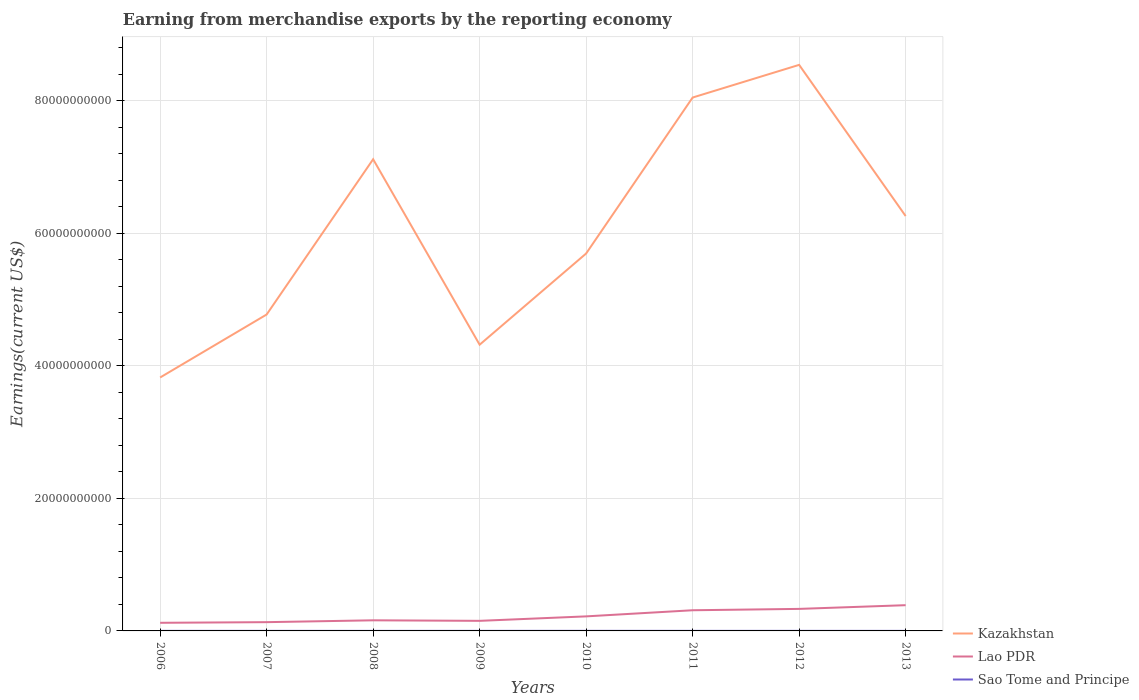Does the line corresponding to Lao PDR intersect with the line corresponding to Kazakhstan?
Make the answer very short. No. Across all years, what is the maximum amount earned from merchandise exports in Lao PDR?
Keep it short and to the point. 1.23e+09. In which year was the amount earned from merchandise exports in Sao Tome and Principe maximum?
Provide a short and direct response. 2008. What is the total amount earned from merchandise exports in Kazakhstan in the graph?
Give a very brief answer. -4.93e+09. What is the difference between the highest and the second highest amount earned from merchandise exports in Lao PDR?
Give a very brief answer. 2.66e+09. What is the difference between the highest and the lowest amount earned from merchandise exports in Kazakhstan?
Your answer should be very brief. 4. Is the amount earned from merchandise exports in Lao PDR strictly greater than the amount earned from merchandise exports in Kazakhstan over the years?
Offer a very short reply. Yes. How many lines are there?
Provide a short and direct response. 3. How many years are there in the graph?
Ensure brevity in your answer.  8. What is the difference between two consecutive major ticks on the Y-axis?
Your response must be concise. 2.00e+1. Does the graph contain grids?
Keep it short and to the point. Yes. How are the legend labels stacked?
Your response must be concise. Vertical. What is the title of the graph?
Ensure brevity in your answer.  Earning from merchandise exports by the reporting economy. Does "Brunei Darussalam" appear as one of the legend labels in the graph?
Provide a short and direct response. No. What is the label or title of the X-axis?
Keep it short and to the point. Years. What is the label or title of the Y-axis?
Give a very brief answer. Earnings(current US$). What is the Earnings(current US$) of Kazakhstan in 2006?
Your answer should be very brief. 3.83e+1. What is the Earnings(current US$) in Lao PDR in 2006?
Provide a short and direct response. 1.23e+09. What is the Earnings(current US$) in Sao Tome and Principe in 2006?
Make the answer very short. 8.39e+06. What is the Earnings(current US$) of Kazakhstan in 2007?
Make the answer very short. 4.78e+1. What is the Earnings(current US$) of Lao PDR in 2007?
Your response must be concise. 1.32e+09. What is the Earnings(current US$) in Sao Tome and Principe in 2007?
Make the answer very short. 8.75e+06. What is the Earnings(current US$) of Kazakhstan in 2008?
Offer a terse response. 7.12e+1. What is the Earnings(current US$) of Lao PDR in 2008?
Ensure brevity in your answer.  1.60e+09. What is the Earnings(current US$) of Sao Tome and Principe in 2008?
Offer a very short reply. 6.57e+06. What is the Earnings(current US$) in Kazakhstan in 2009?
Ensure brevity in your answer.  4.32e+1. What is the Earnings(current US$) of Lao PDR in 2009?
Provide a short and direct response. 1.52e+09. What is the Earnings(current US$) in Sao Tome and Principe in 2009?
Your response must be concise. 9.18e+06. What is the Earnings(current US$) in Kazakhstan in 2010?
Give a very brief answer. 5.70e+1. What is the Earnings(current US$) of Lao PDR in 2010?
Make the answer very short. 2.20e+09. What is the Earnings(current US$) of Sao Tome and Principe in 2010?
Provide a succinct answer. 1.19e+07. What is the Earnings(current US$) in Kazakhstan in 2011?
Keep it short and to the point. 8.05e+1. What is the Earnings(current US$) in Lao PDR in 2011?
Ensure brevity in your answer.  3.12e+09. What is the Earnings(current US$) of Sao Tome and Principe in 2011?
Provide a short and direct response. 8.98e+06. What is the Earnings(current US$) in Kazakhstan in 2012?
Your answer should be very brief. 8.54e+1. What is the Earnings(current US$) in Lao PDR in 2012?
Your answer should be compact. 3.33e+09. What is the Earnings(current US$) in Sao Tome and Principe in 2012?
Your answer should be compact. 8.64e+06. What is the Earnings(current US$) in Kazakhstan in 2013?
Offer a terse response. 6.26e+1. What is the Earnings(current US$) in Lao PDR in 2013?
Provide a short and direct response. 3.88e+09. What is the Earnings(current US$) of Sao Tome and Principe in 2013?
Make the answer very short. 7.57e+06. Across all years, what is the maximum Earnings(current US$) of Kazakhstan?
Your response must be concise. 8.54e+1. Across all years, what is the maximum Earnings(current US$) of Lao PDR?
Offer a very short reply. 3.88e+09. Across all years, what is the maximum Earnings(current US$) in Sao Tome and Principe?
Give a very brief answer. 1.19e+07. Across all years, what is the minimum Earnings(current US$) in Kazakhstan?
Give a very brief answer. 3.83e+1. Across all years, what is the minimum Earnings(current US$) in Lao PDR?
Provide a short and direct response. 1.23e+09. Across all years, what is the minimum Earnings(current US$) of Sao Tome and Principe?
Ensure brevity in your answer.  6.57e+06. What is the total Earnings(current US$) in Kazakhstan in the graph?
Offer a very short reply. 4.86e+11. What is the total Earnings(current US$) of Lao PDR in the graph?
Offer a terse response. 1.82e+1. What is the total Earnings(current US$) of Sao Tome and Principe in the graph?
Your response must be concise. 7.00e+07. What is the difference between the Earnings(current US$) in Kazakhstan in 2006 and that in 2007?
Provide a succinct answer. -9.51e+09. What is the difference between the Earnings(current US$) in Lao PDR in 2006 and that in 2007?
Keep it short and to the point. -9.67e+07. What is the difference between the Earnings(current US$) in Sao Tome and Principe in 2006 and that in 2007?
Your answer should be very brief. -3.64e+05. What is the difference between the Earnings(current US$) of Kazakhstan in 2006 and that in 2008?
Offer a terse response. -3.29e+1. What is the difference between the Earnings(current US$) of Lao PDR in 2006 and that in 2008?
Offer a very short reply. -3.74e+08. What is the difference between the Earnings(current US$) in Sao Tome and Principe in 2006 and that in 2008?
Give a very brief answer. 1.83e+06. What is the difference between the Earnings(current US$) of Kazakhstan in 2006 and that in 2009?
Ensure brevity in your answer.  -4.95e+09. What is the difference between the Earnings(current US$) in Lao PDR in 2006 and that in 2009?
Ensure brevity in your answer.  -2.94e+08. What is the difference between the Earnings(current US$) in Sao Tome and Principe in 2006 and that in 2009?
Make the answer very short. -7.90e+05. What is the difference between the Earnings(current US$) in Kazakhstan in 2006 and that in 2010?
Keep it short and to the point. -1.87e+1. What is the difference between the Earnings(current US$) of Lao PDR in 2006 and that in 2010?
Provide a short and direct response. -9.69e+08. What is the difference between the Earnings(current US$) in Sao Tome and Principe in 2006 and that in 2010?
Provide a succinct answer. -3.49e+06. What is the difference between the Earnings(current US$) in Kazakhstan in 2006 and that in 2011?
Your answer should be very brief. -4.23e+1. What is the difference between the Earnings(current US$) of Lao PDR in 2006 and that in 2011?
Provide a succinct answer. -1.89e+09. What is the difference between the Earnings(current US$) in Sao Tome and Principe in 2006 and that in 2011?
Ensure brevity in your answer.  -5.91e+05. What is the difference between the Earnings(current US$) of Kazakhstan in 2006 and that in 2012?
Provide a succinct answer. -4.72e+1. What is the difference between the Earnings(current US$) in Lao PDR in 2006 and that in 2012?
Provide a succinct answer. -2.10e+09. What is the difference between the Earnings(current US$) in Sao Tome and Principe in 2006 and that in 2012?
Provide a short and direct response. -2.52e+05. What is the difference between the Earnings(current US$) of Kazakhstan in 2006 and that in 2013?
Your answer should be compact. -2.44e+1. What is the difference between the Earnings(current US$) of Lao PDR in 2006 and that in 2013?
Provide a short and direct response. -2.66e+09. What is the difference between the Earnings(current US$) of Sao Tome and Principe in 2006 and that in 2013?
Offer a terse response. 8.24e+05. What is the difference between the Earnings(current US$) of Kazakhstan in 2007 and that in 2008?
Provide a short and direct response. -2.34e+1. What is the difference between the Earnings(current US$) of Lao PDR in 2007 and that in 2008?
Your answer should be very brief. -2.77e+08. What is the difference between the Earnings(current US$) of Sao Tome and Principe in 2007 and that in 2008?
Make the answer very short. 2.19e+06. What is the difference between the Earnings(current US$) in Kazakhstan in 2007 and that in 2009?
Give a very brief answer. 4.56e+09. What is the difference between the Earnings(current US$) of Lao PDR in 2007 and that in 2009?
Provide a short and direct response. -1.98e+08. What is the difference between the Earnings(current US$) in Sao Tome and Principe in 2007 and that in 2009?
Your response must be concise. -4.26e+05. What is the difference between the Earnings(current US$) of Kazakhstan in 2007 and that in 2010?
Give a very brief answer. -9.21e+09. What is the difference between the Earnings(current US$) of Lao PDR in 2007 and that in 2010?
Provide a succinct answer. -8.72e+08. What is the difference between the Earnings(current US$) of Sao Tome and Principe in 2007 and that in 2010?
Keep it short and to the point. -3.13e+06. What is the difference between the Earnings(current US$) of Kazakhstan in 2007 and that in 2011?
Offer a terse response. -3.28e+1. What is the difference between the Earnings(current US$) of Lao PDR in 2007 and that in 2011?
Provide a succinct answer. -1.80e+09. What is the difference between the Earnings(current US$) of Sao Tome and Principe in 2007 and that in 2011?
Your response must be concise. -2.27e+05. What is the difference between the Earnings(current US$) in Kazakhstan in 2007 and that in 2012?
Ensure brevity in your answer.  -3.77e+1. What is the difference between the Earnings(current US$) in Lao PDR in 2007 and that in 2012?
Your response must be concise. -2.00e+09. What is the difference between the Earnings(current US$) in Sao Tome and Principe in 2007 and that in 2012?
Ensure brevity in your answer.  1.12e+05. What is the difference between the Earnings(current US$) of Kazakhstan in 2007 and that in 2013?
Ensure brevity in your answer.  -1.49e+1. What is the difference between the Earnings(current US$) of Lao PDR in 2007 and that in 2013?
Provide a short and direct response. -2.56e+09. What is the difference between the Earnings(current US$) of Sao Tome and Principe in 2007 and that in 2013?
Provide a succinct answer. 1.19e+06. What is the difference between the Earnings(current US$) of Kazakhstan in 2008 and that in 2009?
Offer a terse response. 2.80e+1. What is the difference between the Earnings(current US$) in Lao PDR in 2008 and that in 2009?
Keep it short and to the point. 7.97e+07. What is the difference between the Earnings(current US$) in Sao Tome and Principe in 2008 and that in 2009?
Provide a succinct answer. -2.62e+06. What is the difference between the Earnings(current US$) of Kazakhstan in 2008 and that in 2010?
Make the answer very short. 1.42e+1. What is the difference between the Earnings(current US$) in Lao PDR in 2008 and that in 2010?
Your response must be concise. -5.95e+08. What is the difference between the Earnings(current US$) in Sao Tome and Principe in 2008 and that in 2010?
Your answer should be compact. -5.32e+06. What is the difference between the Earnings(current US$) in Kazakhstan in 2008 and that in 2011?
Give a very brief answer. -9.32e+09. What is the difference between the Earnings(current US$) in Lao PDR in 2008 and that in 2011?
Your response must be concise. -1.52e+09. What is the difference between the Earnings(current US$) of Sao Tome and Principe in 2008 and that in 2011?
Make the answer very short. -2.42e+06. What is the difference between the Earnings(current US$) in Kazakhstan in 2008 and that in 2012?
Ensure brevity in your answer.  -1.42e+1. What is the difference between the Earnings(current US$) of Lao PDR in 2008 and that in 2012?
Keep it short and to the point. -1.73e+09. What is the difference between the Earnings(current US$) in Sao Tome and Principe in 2008 and that in 2012?
Offer a very short reply. -2.08e+06. What is the difference between the Earnings(current US$) of Kazakhstan in 2008 and that in 2013?
Offer a very short reply. 8.57e+09. What is the difference between the Earnings(current US$) of Lao PDR in 2008 and that in 2013?
Ensure brevity in your answer.  -2.28e+09. What is the difference between the Earnings(current US$) in Sao Tome and Principe in 2008 and that in 2013?
Your answer should be very brief. -1.00e+06. What is the difference between the Earnings(current US$) in Kazakhstan in 2009 and that in 2010?
Your answer should be compact. -1.38e+1. What is the difference between the Earnings(current US$) of Lao PDR in 2009 and that in 2010?
Provide a short and direct response. -6.75e+08. What is the difference between the Earnings(current US$) of Sao Tome and Principe in 2009 and that in 2010?
Your response must be concise. -2.70e+06. What is the difference between the Earnings(current US$) of Kazakhstan in 2009 and that in 2011?
Provide a succinct answer. -3.73e+1. What is the difference between the Earnings(current US$) of Lao PDR in 2009 and that in 2011?
Ensure brevity in your answer.  -1.60e+09. What is the difference between the Earnings(current US$) of Sao Tome and Principe in 2009 and that in 2011?
Provide a short and direct response. 1.99e+05. What is the difference between the Earnings(current US$) of Kazakhstan in 2009 and that in 2012?
Give a very brief answer. -4.22e+1. What is the difference between the Earnings(current US$) of Lao PDR in 2009 and that in 2012?
Offer a terse response. -1.81e+09. What is the difference between the Earnings(current US$) in Sao Tome and Principe in 2009 and that in 2012?
Ensure brevity in your answer.  5.38e+05. What is the difference between the Earnings(current US$) of Kazakhstan in 2009 and that in 2013?
Ensure brevity in your answer.  -1.94e+1. What is the difference between the Earnings(current US$) of Lao PDR in 2009 and that in 2013?
Your response must be concise. -2.36e+09. What is the difference between the Earnings(current US$) of Sao Tome and Principe in 2009 and that in 2013?
Ensure brevity in your answer.  1.61e+06. What is the difference between the Earnings(current US$) of Kazakhstan in 2010 and that in 2011?
Your answer should be compact. -2.35e+1. What is the difference between the Earnings(current US$) in Lao PDR in 2010 and that in 2011?
Offer a very short reply. -9.25e+08. What is the difference between the Earnings(current US$) of Sao Tome and Principe in 2010 and that in 2011?
Ensure brevity in your answer.  2.90e+06. What is the difference between the Earnings(current US$) of Kazakhstan in 2010 and that in 2012?
Provide a succinct answer. -2.85e+1. What is the difference between the Earnings(current US$) in Lao PDR in 2010 and that in 2012?
Ensure brevity in your answer.  -1.13e+09. What is the difference between the Earnings(current US$) in Sao Tome and Principe in 2010 and that in 2012?
Keep it short and to the point. 3.24e+06. What is the difference between the Earnings(current US$) of Kazakhstan in 2010 and that in 2013?
Ensure brevity in your answer.  -5.66e+09. What is the difference between the Earnings(current US$) of Lao PDR in 2010 and that in 2013?
Ensure brevity in your answer.  -1.69e+09. What is the difference between the Earnings(current US$) of Sao Tome and Principe in 2010 and that in 2013?
Give a very brief answer. 4.31e+06. What is the difference between the Earnings(current US$) in Kazakhstan in 2011 and that in 2012?
Your answer should be compact. -4.93e+09. What is the difference between the Earnings(current US$) of Lao PDR in 2011 and that in 2012?
Provide a short and direct response. -2.05e+08. What is the difference between the Earnings(current US$) in Sao Tome and Principe in 2011 and that in 2012?
Offer a terse response. 3.39e+05. What is the difference between the Earnings(current US$) of Kazakhstan in 2011 and that in 2013?
Your answer should be compact. 1.79e+1. What is the difference between the Earnings(current US$) of Lao PDR in 2011 and that in 2013?
Offer a terse response. -7.63e+08. What is the difference between the Earnings(current US$) of Sao Tome and Principe in 2011 and that in 2013?
Offer a very short reply. 1.41e+06. What is the difference between the Earnings(current US$) in Kazakhstan in 2012 and that in 2013?
Make the answer very short. 2.28e+1. What is the difference between the Earnings(current US$) in Lao PDR in 2012 and that in 2013?
Keep it short and to the point. -5.58e+08. What is the difference between the Earnings(current US$) of Sao Tome and Principe in 2012 and that in 2013?
Give a very brief answer. 1.08e+06. What is the difference between the Earnings(current US$) of Kazakhstan in 2006 and the Earnings(current US$) of Lao PDR in 2007?
Give a very brief answer. 3.69e+1. What is the difference between the Earnings(current US$) of Kazakhstan in 2006 and the Earnings(current US$) of Sao Tome and Principe in 2007?
Your response must be concise. 3.82e+1. What is the difference between the Earnings(current US$) in Lao PDR in 2006 and the Earnings(current US$) in Sao Tome and Principe in 2007?
Make the answer very short. 1.22e+09. What is the difference between the Earnings(current US$) in Kazakhstan in 2006 and the Earnings(current US$) in Lao PDR in 2008?
Ensure brevity in your answer.  3.67e+1. What is the difference between the Earnings(current US$) in Kazakhstan in 2006 and the Earnings(current US$) in Sao Tome and Principe in 2008?
Your response must be concise. 3.83e+1. What is the difference between the Earnings(current US$) of Lao PDR in 2006 and the Earnings(current US$) of Sao Tome and Principe in 2008?
Offer a very short reply. 1.22e+09. What is the difference between the Earnings(current US$) in Kazakhstan in 2006 and the Earnings(current US$) in Lao PDR in 2009?
Provide a short and direct response. 3.67e+1. What is the difference between the Earnings(current US$) in Kazakhstan in 2006 and the Earnings(current US$) in Sao Tome and Principe in 2009?
Your response must be concise. 3.82e+1. What is the difference between the Earnings(current US$) in Lao PDR in 2006 and the Earnings(current US$) in Sao Tome and Principe in 2009?
Ensure brevity in your answer.  1.22e+09. What is the difference between the Earnings(current US$) of Kazakhstan in 2006 and the Earnings(current US$) of Lao PDR in 2010?
Your answer should be compact. 3.61e+1. What is the difference between the Earnings(current US$) of Kazakhstan in 2006 and the Earnings(current US$) of Sao Tome and Principe in 2010?
Your answer should be very brief. 3.82e+1. What is the difference between the Earnings(current US$) of Lao PDR in 2006 and the Earnings(current US$) of Sao Tome and Principe in 2010?
Your response must be concise. 1.21e+09. What is the difference between the Earnings(current US$) of Kazakhstan in 2006 and the Earnings(current US$) of Lao PDR in 2011?
Ensure brevity in your answer.  3.51e+1. What is the difference between the Earnings(current US$) in Kazakhstan in 2006 and the Earnings(current US$) in Sao Tome and Principe in 2011?
Offer a very short reply. 3.82e+1. What is the difference between the Earnings(current US$) of Lao PDR in 2006 and the Earnings(current US$) of Sao Tome and Principe in 2011?
Offer a very short reply. 1.22e+09. What is the difference between the Earnings(current US$) in Kazakhstan in 2006 and the Earnings(current US$) in Lao PDR in 2012?
Make the answer very short. 3.49e+1. What is the difference between the Earnings(current US$) of Kazakhstan in 2006 and the Earnings(current US$) of Sao Tome and Principe in 2012?
Your answer should be compact. 3.82e+1. What is the difference between the Earnings(current US$) in Lao PDR in 2006 and the Earnings(current US$) in Sao Tome and Principe in 2012?
Offer a terse response. 1.22e+09. What is the difference between the Earnings(current US$) of Kazakhstan in 2006 and the Earnings(current US$) of Lao PDR in 2013?
Provide a short and direct response. 3.44e+1. What is the difference between the Earnings(current US$) of Kazakhstan in 2006 and the Earnings(current US$) of Sao Tome and Principe in 2013?
Ensure brevity in your answer.  3.82e+1. What is the difference between the Earnings(current US$) in Lao PDR in 2006 and the Earnings(current US$) in Sao Tome and Principe in 2013?
Offer a very short reply. 1.22e+09. What is the difference between the Earnings(current US$) in Kazakhstan in 2007 and the Earnings(current US$) in Lao PDR in 2008?
Provide a short and direct response. 4.62e+1. What is the difference between the Earnings(current US$) of Kazakhstan in 2007 and the Earnings(current US$) of Sao Tome and Principe in 2008?
Your answer should be very brief. 4.78e+1. What is the difference between the Earnings(current US$) of Lao PDR in 2007 and the Earnings(current US$) of Sao Tome and Principe in 2008?
Your answer should be very brief. 1.32e+09. What is the difference between the Earnings(current US$) of Kazakhstan in 2007 and the Earnings(current US$) of Lao PDR in 2009?
Provide a succinct answer. 4.62e+1. What is the difference between the Earnings(current US$) of Kazakhstan in 2007 and the Earnings(current US$) of Sao Tome and Principe in 2009?
Make the answer very short. 4.78e+1. What is the difference between the Earnings(current US$) in Lao PDR in 2007 and the Earnings(current US$) in Sao Tome and Principe in 2009?
Provide a short and direct response. 1.31e+09. What is the difference between the Earnings(current US$) in Kazakhstan in 2007 and the Earnings(current US$) in Lao PDR in 2010?
Your answer should be compact. 4.56e+1. What is the difference between the Earnings(current US$) of Kazakhstan in 2007 and the Earnings(current US$) of Sao Tome and Principe in 2010?
Offer a very short reply. 4.78e+1. What is the difference between the Earnings(current US$) in Lao PDR in 2007 and the Earnings(current US$) in Sao Tome and Principe in 2010?
Keep it short and to the point. 1.31e+09. What is the difference between the Earnings(current US$) in Kazakhstan in 2007 and the Earnings(current US$) in Lao PDR in 2011?
Keep it short and to the point. 4.46e+1. What is the difference between the Earnings(current US$) of Kazakhstan in 2007 and the Earnings(current US$) of Sao Tome and Principe in 2011?
Keep it short and to the point. 4.78e+1. What is the difference between the Earnings(current US$) in Lao PDR in 2007 and the Earnings(current US$) in Sao Tome and Principe in 2011?
Provide a short and direct response. 1.31e+09. What is the difference between the Earnings(current US$) of Kazakhstan in 2007 and the Earnings(current US$) of Lao PDR in 2012?
Offer a terse response. 4.44e+1. What is the difference between the Earnings(current US$) of Kazakhstan in 2007 and the Earnings(current US$) of Sao Tome and Principe in 2012?
Your response must be concise. 4.78e+1. What is the difference between the Earnings(current US$) in Lao PDR in 2007 and the Earnings(current US$) in Sao Tome and Principe in 2012?
Your response must be concise. 1.31e+09. What is the difference between the Earnings(current US$) of Kazakhstan in 2007 and the Earnings(current US$) of Lao PDR in 2013?
Make the answer very short. 4.39e+1. What is the difference between the Earnings(current US$) of Kazakhstan in 2007 and the Earnings(current US$) of Sao Tome and Principe in 2013?
Offer a very short reply. 4.78e+1. What is the difference between the Earnings(current US$) in Lao PDR in 2007 and the Earnings(current US$) in Sao Tome and Principe in 2013?
Offer a very short reply. 1.32e+09. What is the difference between the Earnings(current US$) in Kazakhstan in 2008 and the Earnings(current US$) in Lao PDR in 2009?
Offer a terse response. 6.97e+1. What is the difference between the Earnings(current US$) in Kazakhstan in 2008 and the Earnings(current US$) in Sao Tome and Principe in 2009?
Keep it short and to the point. 7.12e+1. What is the difference between the Earnings(current US$) of Lao PDR in 2008 and the Earnings(current US$) of Sao Tome and Principe in 2009?
Provide a short and direct response. 1.59e+09. What is the difference between the Earnings(current US$) of Kazakhstan in 2008 and the Earnings(current US$) of Lao PDR in 2010?
Your answer should be very brief. 6.90e+1. What is the difference between the Earnings(current US$) of Kazakhstan in 2008 and the Earnings(current US$) of Sao Tome and Principe in 2010?
Offer a very short reply. 7.12e+1. What is the difference between the Earnings(current US$) in Lao PDR in 2008 and the Earnings(current US$) in Sao Tome and Principe in 2010?
Your answer should be compact. 1.59e+09. What is the difference between the Earnings(current US$) of Kazakhstan in 2008 and the Earnings(current US$) of Lao PDR in 2011?
Your answer should be very brief. 6.81e+1. What is the difference between the Earnings(current US$) of Kazakhstan in 2008 and the Earnings(current US$) of Sao Tome and Principe in 2011?
Your answer should be very brief. 7.12e+1. What is the difference between the Earnings(current US$) in Lao PDR in 2008 and the Earnings(current US$) in Sao Tome and Principe in 2011?
Your response must be concise. 1.59e+09. What is the difference between the Earnings(current US$) of Kazakhstan in 2008 and the Earnings(current US$) of Lao PDR in 2012?
Your response must be concise. 6.79e+1. What is the difference between the Earnings(current US$) in Kazakhstan in 2008 and the Earnings(current US$) in Sao Tome and Principe in 2012?
Offer a terse response. 7.12e+1. What is the difference between the Earnings(current US$) in Lao PDR in 2008 and the Earnings(current US$) in Sao Tome and Principe in 2012?
Your answer should be very brief. 1.59e+09. What is the difference between the Earnings(current US$) of Kazakhstan in 2008 and the Earnings(current US$) of Lao PDR in 2013?
Keep it short and to the point. 6.73e+1. What is the difference between the Earnings(current US$) of Kazakhstan in 2008 and the Earnings(current US$) of Sao Tome and Principe in 2013?
Offer a very short reply. 7.12e+1. What is the difference between the Earnings(current US$) in Lao PDR in 2008 and the Earnings(current US$) in Sao Tome and Principe in 2013?
Your answer should be compact. 1.59e+09. What is the difference between the Earnings(current US$) in Kazakhstan in 2009 and the Earnings(current US$) in Lao PDR in 2010?
Make the answer very short. 4.10e+1. What is the difference between the Earnings(current US$) of Kazakhstan in 2009 and the Earnings(current US$) of Sao Tome and Principe in 2010?
Your response must be concise. 4.32e+1. What is the difference between the Earnings(current US$) in Lao PDR in 2009 and the Earnings(current US$) in Sao Tome and Principe in 2010?
Keep it short and to the point. 1.51e+09. What is the difference between the Earnings(current US$) in Kazakhstan in 2009 and the Earnings(current US$) in Lao PDR in 2011?
Make the answer very short. 4.01e+1. What is the difference between the Earnings(current US$) of Kazakhstan in 2009 and the Earnings(current US$) of Sao Tome and Principe in 2011?
Make the answer very short. 4.32e+1. What is the difference between the Earnings(current US$) in Lao PDR in 2009 and the Earnings(current US$) in Sao Tome and Principe in 2011?
Make the answer very short. 1.51e+09. What is the difference between the Earnings(current US$) of Kazakhstan in 2009 and the Earnings(current US$) of Lao PDR in 2012?
Ensure brevity in your answer.  3.99e+1. What is the difference between the Earnings(current US$) in Kazakhstan in 2009 and the Earnings(current US$) in Sao Tome and Principe in 2012?
Your answer should be compact. 4.32e+1. What is the difference between the Earnings(current US$) of Lao PDR in 2009 and the Earnings(current US$) of Sao Tome and Principe in 2012?
Ensure brevity in your answer.  1.51e+09. What is the difference between the Earnings(current US$) of Kazakhstan in 2009 and the Earnings(current US$) of Lao PDR in 2013?
Make the answer very short. 3.93e+1. What is the difference between the Earnings(current US$) in Kazakhstan in 2009 and the Earnings(current US$) in Sao Tome and Principe in 2013?
Offer a terse response. 4.32e+1. What is the difference between the Earnings(current US$) in Lao PDR in 2009 and the Earnings(current US$) in Sao Tome and Principe in 2013?
Ensure brevity in your answer.  1.51e+09. What is the difference between the Earnings(current US$) in Kazakhstan in 2010 and the Earnings(current US$) in Lao PDR in 2011?
Ensure brevity in your answer.  5.39e+1. What is the difference between the Earnings(current US$) in Kazakhstan in 2010 and the Earnings(current US$) in Sao Tome and Principe in 2011?
Your response must be concise. 5.70e+1. What is the difference between the Earnings(current US$) in Lao PDR in 2010 and the Earnings(current US$) in Sao Tome and Principe in 2011?
Make the answer very short. 2.19e+09. What is the difference between the Earnings(current US$) of Kazakhstan in 2010 and the Earnings(current US$) of Lao PDR in 2012?
Offer a very short reply. 5.36e+1. What is the difference between the Earnings(current US$) in Kazakhstan in 2010 and the Earnings(current US$) in Sao Tome and Principe in 2012?
Ensure brevity in your answer.  5.70e+1. What is the difference between the Earnings(current US$) of Lao PDR in 2010 and the Earnings(current US$) of Sao Tome and Principe in 2012?
Your answer should be very brief. 2.19e+09. What is the difference between the Earnings(current US$) of Kazakhstan in 2010 and the Earnings(current US$) of Lao PDR in 2013?
Keep it short and to the point. 5.31e+1. What is the difference between the Earnings(current US$) in Kazakhstan in 2010 and the Earnings(current US$) in Sao Tome and Principe in 2013?
Ensure brevity in your answer.  5.70e+1. What is the difference between the Earnings(current US$) of Lao PDR in 2010 and the Earnings(current US$) of Sao Tome and Principe in 2013?
Offer a terse response. 2.19e+09. What is the difference between the Earnings(current US$) of Kazakhstan in 2011 and the Earnings(current US$) of Lao PDR in 2012?
Ensure brevity in your answer.  7.72e+1. What is the difference between the Earnings(current US$) in Kazakhstan in 2011 and the Earnings(current US$) in Sao Tome and Principe in 2012?
Make the answer very short. 8.05e+1. What is the difference between the Earnings(current US$) of Lao PDR in 2011 and the Earnings(current US$) of Sao Tome and Principe in 2012?
Keep it short and to the point. 3.11e+09. What is the difference between the Earnings(current US$) in Kazakhstan in 2011 and the Earnings(current US$) in Lao PDR in 2013?
Your response must be concise. 7.66e+1. What is the difference between the Earnings(current US$) of Kazakhstan in 2011 and the Earnings(current US$) of Sao Tome and Principe in 2013?
Your answer should be compact. 8.05e+1. What is the difference between the Earnings(current US$) of Lao PDR in 2011 and the Earnings(current US$) of Sao Tome and Principe in 2013?
Your response must be concise. 3.11e+09. What is the difference between the Earnings(current US$) of Kazakhstan in 2012 and the Earnings(current US$) of Lao PDR in 2013?
Keep it short and to the point. 8.16e+1. What is the difference between the Earnings(current US$) in Kazakhstan in 2012 and the Earnings(current US$) in Sao Tome and Principe in 2013?
Your answer should be compact. 8.54e+1. What is the difference between the Earnings(current US$) of Lao PDR in 2012 and the Earnings(current US$) of Sao Tome and Principe in 2013?
Provide a succinct answer. 3.32e+09. What is the average Earnings(current US$) of Kazakhstan per year?
Keep it short and to the point. 6.07e+1. What is the average Earnings(current US$) of Lao PDR per year?
Offer a very short reply. 2.27e+09. What is the average Earnings(current US$) in Sao Tome and Principe per year?
Your answer should be compact. 8.75e+06. In the year 2006, what is the difference between the Earnings(current US$) in Kazakhstan and Earnings(current US$) in Lao PDR?
Offer a very short reply. 3.70e+1. In the year 2006, what is the difference between the Earnings(current US$) in Kazakhstan and Earnings(current US$) in Sao Tome and Principe?
Keep it short and to the point. 3.82e+1. In the year 2006, what is the difference between the Earnings(current US$) of Lao PDR and Earnings(current US$) of Sao Tome and Principe?
Give a very brief answer. 1.22e+09. In the year 2007, what is the difference between the Earnings(current US$) in Kazakhstan and Earnings(current US$) in Lao PDR?
Provide a short and direct response. 4.64e+1. In the year 2007, what is the difference between the Earnings(current US$) of Kazakhstan and Earnings(current US$) of Sao Tome and Principe?
Your response must be concise. 4.78e+1. In the year 2007, what is the difference between the Earnings(current US$) in Lao PDR and Earnings(current US$) in Sao Tome and Principe?
Your answer should be compact. 1.31e+09. In the year 2008, what is the difference between the Earnings(current US$) of Kazakhstan and Earnings(current US$) of Lao PDR?
Make the answer very short. 6.96e+1. In the year 2008, what is the difference between the Earnings(current US$) of Kazakhstan and Earnings(current US$) of Sao Tome and Principe?
Keep it short and to the point. 7.12e+1. In the year 2008, what is the difference between the Earnings(current US$) in Lao PDR and Earnings(current US$) in Sao Tome and Principe?
Offer a very short reply. 1.59e+09. In the year 2009, what is the difference between the Earnings(current US$) in Kazakhstan and Earnings(current US$) in Lao PDR?
Make the answer very short. 4.17e+1. In the year 2009, what is the difference between the Earnings(current US$) in Kazakhstan and Earnings(current US$) in Sao Tome and Principe?
Keep it short and to the point. 4.32e+1. In the year 2009, what is the difference between the Earnings(current US$) of Lao PDR and Earnings(current US$) of Sao Tome and Principe?
Your response must be concise. 1.51e+09. In the year 2010, what is the difference between the Earnings(current US$) of Kazakhstan and Earnings(current US$) of Lao PDR?
Give a very brief answer. 5.48e+1. In the year 2010, what is the difference between the Earnings(current US$) in Kazakhstan and Earnings(current US$) in Sao Tome and Principe?
Provide a short and direct response. 5.70e+1. In the year 2010, what is the difference between the Earnings(current US$) of Lao PDR and Earnings(current US$) of Sao Tome and Principe?
Offer a very short reply. 2.18e+09. In the year 2011, what is the difference between the Earnings(current US$) in Kazakhstan and Earnings(current US$) in Lao PDR?
Keep it short and to the point. 7.74e+1. In the year 2011, what is the difference between the Earnings(current US$) of Kazakhstan and Earnings(current US$) of Sao Tome and Principe?
Your answer should be compact. 8.05e+1. In the year 2011, what is the difference between the Earnings(current US$) of Lao PDR and Earnings(current US$) of Sao Tome and Principe?
Your response must be concise. 3.11e+09. In the year 2012, what is the difference between the Earnings(current US$) in Kazakhstan and Earnings(current US$) in Lao PDR?
Your response must be concise. 8.21e+1. In the year 2012, what is the difference between the Earnings(current US$) of Kazakhstan and Earnings(current US$) of Sao Tome and Principe?
Your response must be concise. 8.54e+1. In the year 2012, what is the difference between the Earnings(current US$) of Lao PDR and Earnings(current US$) of Sao Tome and Principe?
Your response must be concise. 3.32e+09. In the year 2013, what is the difference between the Earnings(current US$) of Kazakhstan and Earnings(current US$) of Lao PDR?
Your answer should be very brief. 5.87e+1. In the year 2013, what is the difference between the Earnings(current US$) of Kazakhstan and Earnings(current US$) of Sao Tome and Principe?
Ensure brevity in your answer.  6.26e+1. In the year 2013, what is the difference between the Earnings(current US$) of Lao PDR and Earnings(current US$) of Sao Tome and Principe?
Your answer should be very brief. 3.88e+09. What is the ratio of the Earnings(current US$) in Kazakhstan in 2006 to that in 2007?
Your answer should be compact. 0.8. What is the ratio of the Earnings(current US$) in Lao PDR in 2006 to that in 2007?
Provide a short and direct response. 0.93. What is the ratio of the Earnings(current US$) in Sao Tome and Principe in 2006 to that in 2007?
Make the answer very short. 0.96. What is the ratio of the Earnings(current US$) in Kazakhstan in 2006 to that in 2008?
Offer a very short reply. 0.54. What is the ratio of the Earnings(current US$) in Lao PDR in 2006 to that in 2008?
Provide a succinct answer. 0.77. What is the ratio of the Earnings(current US$) in Sao Tome and Principe in 2006 to that in 2008?
Make the answer very short. 1.28. What is the ratio of the Earnings(current US$) in Kazakhstan in 2006 to that in 2009?
Provide a short and direct response. 0.89. What is the ratio of the Earnings(current US$) of Lao PDR in 2006 to that in 2009?
Provide a short and direct response. 0.81. What is the ratio of the Earnings(current US$) in Sao Tome and Principe in 2006 to that in 2009?
Offer a terse response. 0.91. What is the ratio of the Earnings(current US$) in Kazakhstan in 2006 to that in 2010?
Your answer should be compact. 0.67. What is the ratio of the Earnings(current US$) of Lao PDR in 2006 to that in 2010?
Offer a terse response. 0.56. What is the ratio of the Earnings(current US$) of Sao Tome and Principe in 2006 to that in 2010?
Offer a very short reply. 0.71. What is the ratio of the Earnings(current US$) in Kazakhstan in 2006 to that in 2011?
Ensure brevity in your answer.  0.48. What is the ratio of the Earnings(current US$) in Lao PDR in 2006 to that in 2011?
Keep it short and to the point. 0.39. What is the ratio of the Earnings(current US$) in Sao Tome and Principe in 2006 to that in 2011?
Provide a succinct answer. 0.93. What is the ratio of the Earnings(current US$) in Kazakhstan in 2006 to that in 2012?
Offer a very short reply. 0.45. What is the ratio of the Earnings(current US$) in Lao PDR in 2006 to that in 2012?
Provide a succinct answer. 0.37. What is the ratio of the Earnings(current US$) of Sao Tome and Principe in 2006 to that in 2012?
Your answer should be very brief. 0.97. What is the ratio of the Earnings(current US$) of Kazakhstan in 2006 to that in 2013?
Provide a succinct answer. 0.61. What is the ratio of the Earnings(current US$) of Lao PDR in 2006 to that in 2013?
Offer a very short reply. 0.32. What is the ratio of the Earnings(current US$) in Sao Tome and Principe in 2006 to that in 2013?
Ensure brevity in your answer.  1.11. What is the ratio of the Earnings(current US$) in Kazakhstan in 2007 to that in 2008?
Your response must be concise. 0.67. What is the ratio of the Earnings(current US$) of Lao PDR in 2007 to that in 2008?
Give a very brief answer. 0.83. What is the ratio of the Earnings(current US$) in Sao Tome and Principe in 2007 to that in 2008?
Your answer should be compact. 1.33. What is the ratio of the Earnings(current US$) of Kazakhstan in 2007 to that in 2009?
Offer a terse response. 1.11. What is the ratio of the Earnings(current US$) in Lao PDR in 2007 to that in 2009?
Provide a short and direct response. 0.87. What is the ratio of the Earnings(current US$) of Sao Tome and Principe in 2007 to that in 2009?
Ensure brevity in your answer.  0.95. What is the ratio of the Earnings(current US$) in Kazakhstan in 2007 to that in 2010?
Your answer should be very brief. 0.84. What is the ratio of the Earnings(current US$) of Lao PDR in 2007 to that in 2010?
Your answer should be compact. 0.6. What is the ratio of the Earnings(current US$) of Sao Tome and Principe in 2007 to that in 2010?
Your answer should be compact. 0.74. What is the ratio of the Earnings(current US$) in Kazakhstan in 2007 to that in 2011?
Your answer should be very brief. 0.59. What is the ratio of the Earnings(current US$) in Lao PDR in 2007 to that in 2011?
Offer a very short reply. 0.42. What is the ratio of the Earnings(current US$) in Sao Tome and Principe in 2007 to that in 2011?
Your answer should be compact. 0.97. What is the ratio of the Earnings(current US$) in Kazakhstan in 2007 to that in 2012?
Your response must be concise. 0.56. What is the ratio of the Earnings(current US$) of Lao PDR in 2007 to that in 2012?
Your answer should be compact. 0.4. What is the ratio of the Earnings(current US$) in Sao Tome and Principe in 2007 to that in 2012?
Make the answer very short. 1.01. What is the ratio of the Earnings(current US$) of Kazakhstan in 2007 to that in 2013?
Your answer should be compact. 0.76. What is the ratio of the Earnings(current US$) in Lao PDR in 2007 to that in 2013?
Provide a succinct answer. 0.34. What is the ratio of the Earnings(current US$) of Sao Tome and Principe in 2007 to that in 2013?
Ensure brevity in your answer.  1.16. What is the ratio of the Earnings(current US$) in Kazakhstan in 2008 to that in 2009?
Provide a succinct answer. 1.65. What is the ratio of the Earnings(current US$) in Lao PDR in 2008 to that in 2009?
Make the answer very short. 1.05. What is the ratio of the Earnings(current US$) of Sao Tome and Principe in 2008 to that in 2009?
Offer a very short reply. 0.72. What is the ratio of the Earnings(current US$) in Kazakhstan in 2008 to that in 2010?
Make the answer very short. 1.25. What is the ratio of the Earnings(current US$) in Lao PDR in 2008 to that in 2010?
Provide a short and direct response. 0.73. What is the ratio of the Earnings(current US$) of Sao Tome and Principe in 2008 to that in 2010?
Ensure brevity in your answer.  0.55. What is the ratio of the Earnings(current US$) in Kazakhstan in 2008 to that in 2011?
Give a very brief answer. 0.88. What is the ratio of the Earnings(current US$) in Lao PDR in 2008 to that in 2011?
Offer a very short reply. 0.51. What is the ratio of the Earnings(current US$) in Sao Tome and Principe in 2008 to that in 2011?
Keep it short and to the point. 0.73. What is the ratio of the Earnings(current US$) of Kazakhstan in 2008 to that in 2012?
Ensure brevity in your answer.  0.83. What is the ratio of the Earnings(current US$) in Lao PDR in 2008 to that in 2012?
Provide a short and direct response. 0.48. What is the ratio of the Earnings(current US$) in Sao Tome and Principe in 2008 to that in 2012?
Offer a very short reply. 0.76. What is the ratio of the Earnings(current US$) of Kazakhstan in 2008 to that in 2013?
Your answer should be very brief. 1.14. What is the ratio of the Earnings(current US$) of Lao PDR in 2008 to that in 2013?
Offer a very short reply. 0.41. What is the ratio of the Earnings(current US$) in Sao Tome and Principe in 2008 to that in 2013?
Give a very brief answer. 0.87. What is the ratio of the Earnings(current US$) in Kazakhstan in 2009 to that in 2010?
Offer a terse response. 0.76. What is the ratio of the Earnings(current US$) in Lao PDR in 2009 to that in 2010?
Give a very brief answer. 0.69. What is the ratio of the Earnings(current US$) of Sao Tome and Principe in 2009 to that in 2010?
Ensure brevity in your answer.  0.77. What is the ratio of the Earnings(current US$) in Kazakhstan in 2009 to that in 2011?
Offer a terse response. 0.54. What is the ratio of the Earnings(current US$) in Lao PDR in 2009 to that in 2011?
Provide a short and direct response. 0.49. What is the ratio of the Earnings(current US$) in Sao Tome and Principe in 2009 to that in 2011?
Keep it short and to the point. 1.02. What is the ratio of the Earnings(current US$) in Kazakhstan in 2009 to that in 2012?
Your answer should be compact. 0.51. What is the ratio of the Earnings(current US$) in Lao PDR in 2009 to that in 2012?
Your answer should be compact. 0.46. What is the ratio of the Earnings(current US$) of Sao Tome and Principe in 2009 to that in 2012?
Make the answer very short. 1.06. What is the ratio of the Earnings(current US$) in Kazakhstan in 2009 to that in 2013?
Keep it short and to the point. 0.69. What is the ratio of the Earnings(current US$) of Lao PDR in 2009 to that in 2013?
Offer a terse response. 0.39. What is the ratio of the Earnings(current US$) of Sao Tome and Principe in 2009 to that in 2013?
Your response must be concise. 1.21. What is the ratio of the Earnings(current US$) of Kazakhstan in 2010 to that in 2011?
Provide a short and direct response. 0.71. What is the ratio of the Earnings(current US$) in Lao PDR in 2010 to that in 2011?
Make the answer very short. 0.7. What is the ratio of the Earnings(current US$) of Sao Tome and Principe in 2010 to that in 2011?
Ensure brevity in your answer.  1.32. What is the ratio of the Earnings(current US$) in Kazakhstan in 2010 to that in 2012?
Your answer should be very brief. 0.67. What is the ratio of the Earnings(current US$) of Lao PDR in 2010 to that in 2012?
Offer a terse response. 0.66. What is the ratio of the Earnings(current US$) of Sao Tome and Principe in 2010 to that in 2012?
Your answer should be very brief. 1.37. What is the ratio of the Earnings(current US$) of Kazakhstan in 2010 to that in 2013?
Give a very brief answer. 0.91. What is the ratio of the Earnings(current US$) in Lao PDR in 2010 to that in 2013?
Keep it short and to the point. 0.57. What is the ratio of the Earnings(current US$) of Sao Tome and Principe in 2010 to that in 2013?
Offer a very short reply. 1.57. What is the ratio of the Earnings(current US$) in Kazakhstan in 2011 to that in 2012?
Ensure brevity in your answer.  0.94. What is the ratio of the Earnings(current US$) in Lao PDR in 2011 to that in 2012?
Make the answer very short. 0.94. What is the ratio of the Earnings(current US$) of Sao Tome and Principe in 2011 to that in 2012?
Offer a terse response. 1.04. What is the ratio of the Earnings(current US$) of Kazakhstan in 2011 to that in 2013?
Offer a very short reply. 1.29. What is the ratio of the Earnings(current US$) in Lao PDR in 2011 to that in 2013?
Offer a very short reply. 0.8. What is the ratio of the Earnings(current US$) of Sao Tome and Principe in 2011 to that in 2013?
Ensure brevity in your answer.  1.19. What is the ratio of the Earnings(current US$) of Kazakhstan in 2012 to that in 2013?
Offer a terse response. 1.36. What is the ratio of the Earnings(current US$) in Lao PDR in 2012 to that in 2013?
Give a very brief answer. 0.86. What is the ratio of the Earnings(current US$) of Sao Tome and Principe in 2012 to that in 2013?
Offer a terse response. 1.14. What is the difference between the highest and the second highest Earnings(current US$) in Kazakhstan?
Your answer should be very brief. 4.93e+09. What is the difference between the highest and the second highest Earnings(current US$) in Lao PDR?
Your answer should be compact. 5.58e+08. What is the difference between the highest and the second highest Earnings(current US$) of Sao Tome and Principe?
Ensure brevity in your answer.  2.70e+06. What is the difference between the highest and the lowest Earnings(current US$) of Kazakhstan?
Your answer should be very brief. 4.72e+1. What is the difference between the highest and the lowest Earnings(current US$) of Lao PDR?
Ensure brevity in your answer.  2.66e+09. What is the difference between the highest and the lowest Earnings(current US$) of Sao Tome and Principe?
Ensure brevity in your answer.  5.32e+06. 